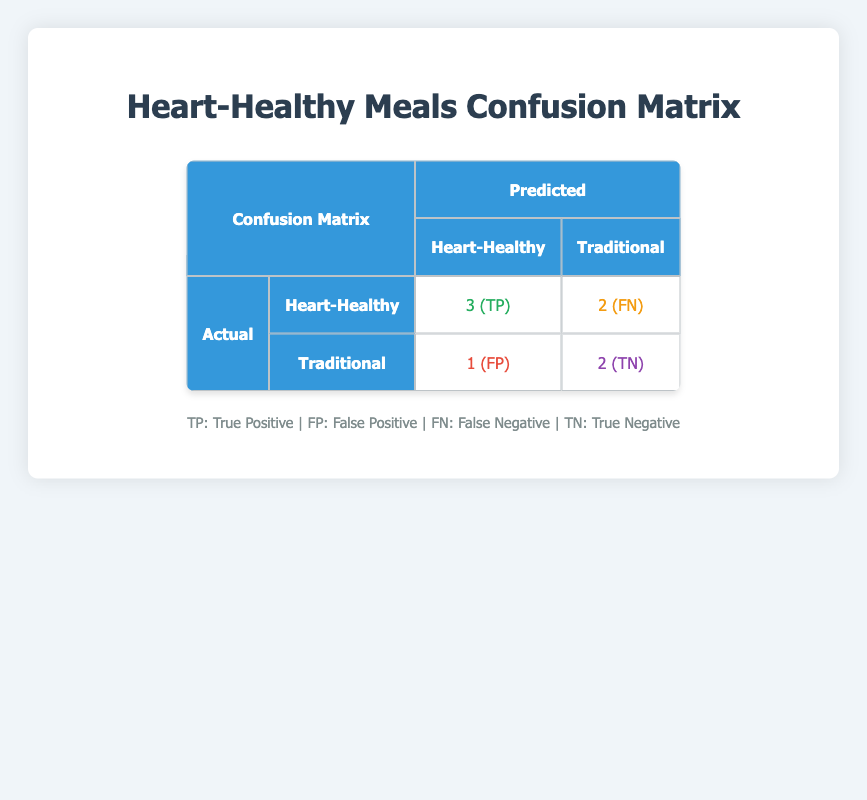What is the number of true positives in the confusion matrix? The confusion matrix indicates that true positives (TP) are found in the "Heart-Healthy" category, where 3 meals were classified correctly as heart-healthy.
Answer: 3 How many meals were predicted as traditional but were actually heart-healthy? From the confusion matrix, the meals that were predicted as traditional but were actually heart-healthy are described as false negatives (FN). The value for FN is 2.
Answer: 2 What is the total number of heart-healthy meals evaluated by the users? To find the total number of heart-healthy meals, we add the true positives and false negatives: 3 (TP) + 2 (FN) = 5.
Answer: 5 What percentage of users were satisfied with heart-healthy meals? Users were satisfied with heart-healthy meals indicated by true positives and false negatives; calculating the percentage: (true positives / total heart-healthy meals) x 100 = (3 / 5) x 100 = 60%.
Answer: 60% Is the number of true negatives greater than the number of false positives? Looking at the confusion matrix, true negatives (TN) amount to 2, while false positives (FP) are 1. Since 2 is greater than 1, the answer is yes.
Answer: Yes What is the difference between true negatives and true positives? The number of true negatives is 2 and the number of true positives is 3. The difference is: 3 - 2 = 1.
Answer: 1 How many meals were falsely categorized as heart-healthy in the predictions? According to the confusion matrix, false positives (FP) represent the meals that were incorrectly predicted as heart-healthy when they are actually traditional. This number is 1.
Answer: 1 What is the total number of traditional meals evaluated by the users? To find the total number of traditional meals evaluated, we add true negatives and false positives: 2 (TN) + 1 (FP) = 3.
Answer: 3 Which category had a higher satisfaction based on positive predictions, heart-healthy or traditional? Heart-healthy meals had 3 true positives, while traditional meals had 2 true negatives. Since we are looking at positive predictions (TP for heart-healthy, TN for traditional), heart-healthy has a higher satisfaction rate.
Answer: Heart-Healthy 